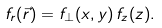Convert formula to latex. <formula><loc_0><loc_0><loc_500><loc_500>f _ { r } ( \vec { r } ) = f _ { \perp } ( x , y ) \, f _ { z } ( z ) .</formula> 